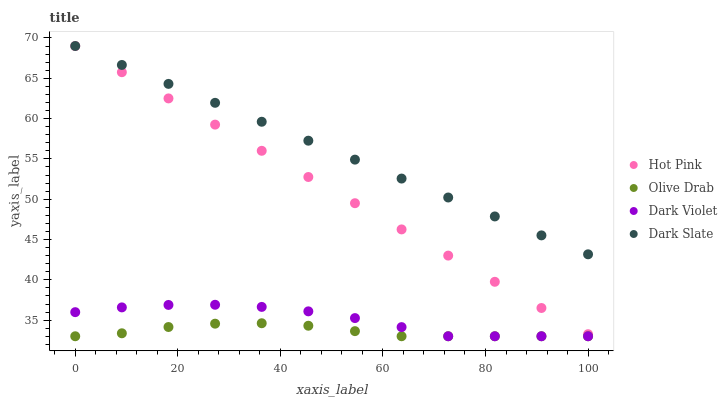Does Olive Drab have the minimum area under the curve?
Answer yes or no. Yes. Does Dark Slate have the maximum area under the curve?
Answer yes or no. Yes. Does Hot Pink have the minimum area under the curve?
Answer yes or no. No. Does Hot Pink have the maximum area under the curve?
Answer yes or no. No. Is Dark Slate the smoothest?
Answer yes or no. Yes. Is Dark Violet the roughest?
Answer yes or no. Yes. Is Hot Pink the smoothest?
Answer yes or no. No. Is Hot Pink the roughest?
Answer yes or no. No. Does Dark Violet have the lowest value?
Answer yes or no. Yes. Does Hot Pink have the lowest value?
Answer yes or no. No. Does Hot Pink have the highest value?
Answer yes or no. Yes. Does Dark Violet have the highest value?
Answer yes or no. No. Is Dark Violet less than Dark Slate?
Answer yes or no. Yes. Is Dark Slate greater than Dark Violet?
Answer yes or no. Yes. Does Hot Pink intersect Dark Slate?
Answer yes or no. Yes. Is Hot Pink less than Dark Slate?
Answer yes or no. No. Is Hot Pink greater than Dark Slate?
Answer yes or no. No. Does Dark Violet intersect Dark Slate?
Answer yes or no. No. 